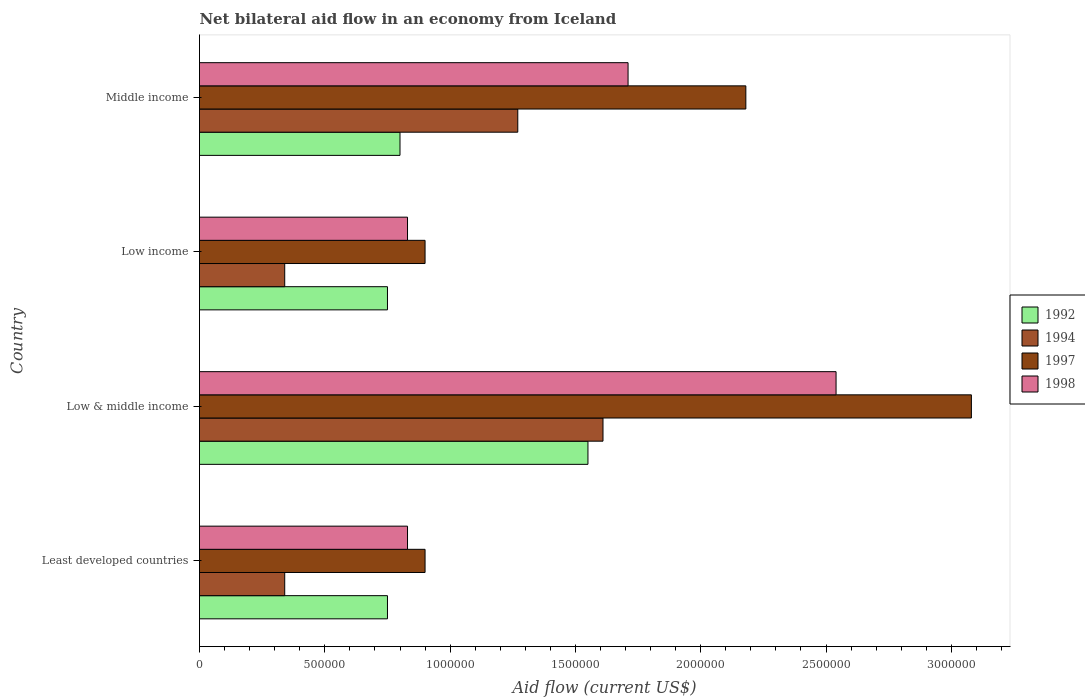How many groups of bars are there?
Keep it short and to the point. 4. Are the number of bars per tick equal to the number of legend labels?
Ensure brevity in your answer.  Yes. Are the number of bars on each tick of the Y-axis equal?
Your answer should be very brief. Yes. What is the label of the 3rd group of bars from the top?
Your answer should be compact. Low & middle income. In how many cases, is the number of bars for a given country not equal to the number of legend labels?
Your answer should be compact. 0. What is the net bilateral aid flow in 1992 in Least developed countries?
Offer a terse response. 7.50e+05. Across all countries, what is the maximum net bilateral aid flow in 1994?
Offer a terse response. 1.61e+06. In which country was the net bilateral aid flow in 1998 minimum?
Ensure brevity in your answer.  Least developed countries. What is the total net bilateral aid flow in 1997 in the graph?
Make the answer very short. 7.06e+06. What is the difference between the net bilateral aid flow in 1997 in Least developed countries and that in Middle income?
Your response must be concise. -1.28e+06. What is the average net bilateral aid flow in 1998 per country?
Offer a terse response. 1.48e+06. What is the difference between the net bilateral aid flow in 1997 and net bilateral aid flow in 1992 in Middle income?
Offer a terse response. 1.38e+06. In how many countries, is the net bilateral aid flow in 1998 greater than 1700000 US$?
Your answer should be very brief. 2. What is the ratio of the net bilateral aid flow in 1998 in Low & middle income to that in Middle income?
Your answer should be very brief. 1.49. Is the net bilateral aid flow in 1992 in Least developed countries less than that in Middle income?
Your answer should be very brief. Yes. What is the difference between the highest and the second highest net bilateral aid flow in 1998?
Ensure brevity in your answer.  8.30e+05. What is the difference between the highest and the lowest net bilateral aid flow in 1994?
Provide a succinct answer. 1.27e+06. In how many countries, is the net bilateral aid flow in 1997 greater than the average net bilateral aid flow in 1997 taken over all countries?
Your response must be concise. 2. Is the sum of the net bilateral aid flow in 1992 in Low & middle income and Low income greater than the maximum net bilateral aid flow in 1998 across all countries?
Provide a short and direct response. No. Is it the case that in every country, the sum of the net bilateral aid flow in 1998 and net bilateral aid flow in 1997 is greater than the net bilateral aid flow in 1992?
Your answer should be compact. Yes. Are all the bars in the graph horizontal?
Offer a very short reply. Yes. What is the difference between two consecutive major ticks on the X-axis?
Offer a terse response. 5.00e+05. Are the values on the major ticks of X-axis written in scientific E-notation?
Ensure brevity in your answer.  No. Does the graph contain any zero values?
Keep it short and to the point. No. Does the graph contain grids?
Make the answer very short. No. Where does the legend appear in the graph?
Offer a terse response. Center right. How many legend labels are there?
Your response must be concise. 4. What is the title of the graph?
Provide a succinct answer. Net bilateral aid flow in an economy from Iceland. Does "1992" appear as one of the legend labels in the graph?
Offer a very short reply. Yes. What is the Aid flow (current US$) of 1992 in Least developed countries?
Your response must be concise. 7.50e+05. What is the Aid flow (current US$) of 1994 in Least developed countries?
Give a very brief answer. 3.40e+05. What is the Aid flow (current US$) of 1997 in Least developed countries?
Offer a terse response. 9.00e+05. What is the Aid flow (current US$) of 1998 in Least developed countries?
Make the answer very short. 8.30e+05. What is the Aid flow (current US$) in 1992 in Low & middle income?
Make the answer very short. 1.55e+06. What is the Aid flow (current US$) in 1994 in Low & middle income?
Provide a short and direct response. 1.61e+06. What is the Aid flow (current US$) of 1997 in Low & middle income?
Make the answer very short. 3.08e+06. What is the Aid flow (current US$) in 1998 in Low & middle income?
Make the answer very short. 2.54e+06. What is the Aid flow (current US$) in 1992 in Low income?
Ensure brevity in your answer.  7.50e+05. What is the Aid flow (current US$) in 1994 in Low income?
Give a very brief answer. 3.40e+05. What is the Aid flow (current US$) in 1998 in Low income?
Your answer should be very brief. 8.30e+05. What is the Aid flow (current US$) in 1992 in Middle income?
Make the answer very short. 8.00e+05. What is the Aid flow (current US$) of 1994 in Middle income?
Provide a succinct answer. 1.27e+06. What is the Aid flow (current US$) in 1997 in Middle income?
Offer a terse response. 2.18e+06. What is the Aid flow (current US$) of 1998 in Middle income?
Your response must be concise. 1.71e+06. Across all countries, what is the maximum Aid flow (current US$) of 1992?
Your answer should be compact. 1.55e+06. Across all countries, what is the maximum Aid flow (current US$) of 1994?
Your answer should be very brief. 1.61e+06. Across all countries, what is the maximum Aid flow (current US$) in 1997?
Provide a short and direct response. 3.08e+06. Across all countries, what is the maximum Aid flow (current US$) in 1998?
Your answer should be compact. 2.54e+06. Across all countries, what is the minimum Aid flow (current US$) in 1992?
Keep it short and to the point. 7.50e+05. Across all countries, what is the minimum Aid flow (current US$) of 1994?
Provide a succinct answer. 3.40e+05. Across all countries, what is the minimum Aid flow (current US$) of 1998?
Your answer should be compact. 8.30e+05. What is the total Aid flow (current US$) of 1992 in the graph?
Your response must be concise. 3.85e+06. What is the total Aid flow (current US$) in 1994 in the graph?
Your response must be concise. 3.56e+06. What is the total Aid flow (current US$) of 1997 in the graph?
Keep it short and to the point. 7.06e+06. What is the total Aid flow (current US$) in 1998 in the graph?
Your answer should be compact. 5.91e+06. What is the difference between the Aid flow (current US$) in 1992 in Least developed countries and that in Low & middle income?
Your response must be concise. -8.00e+05. What is the difference between the Aid flow (current US$) of 1994 in Least developed countries and that in Low & middle income?
Ensure brevity in your answer.  -1.27e+06. What is the difference between the Aid flow (current US$) of 1997 in Least developed countries and that in Low & middle income?
Your response must be concise. -2.18e+06. What is the difference between the Aid flow (current US$) in 1998 in Least developed countries and that in Low & middle income?
Make the answer very short. -1.71e+06. What is the difference between the Aid flow (current US$) in 1992 in Least developed countries and that in Low income?
Ensure brevity in your answer.  0. What is the difference between the Aid flow (current US$) of 1994 in Least developed countries and that in Low income?
Provide a short and direct response. 0. What is the difference between the Aid flow (current US$) in 1997 in Least developed countries and that in Low income?
Make the answer very short. 0. What is the difference between the Aid flow (current US$) of 1998 in Least developed countries and that in Low income?
Your response must be concise. 0. What is the difference between the Aid flow (current US$) of 1992 in Least developed countries and that in Middle income?
Your answer should be very brief. -5.00e+04. What is the difference between the Aid flow (current US$) of 1994 in Least developed countries and that in Middle income?
Provide a short and direct response. -9.30e+05. What is the difference between the Aid flow (current US$) of 1997 in Least developed countries and that in Middle income?
Offer a terse response. -1.28e+06. What is the difference between the Aid flow (current US$) in 1998 in Least developed countries and that in Middle income?
Your answer should be very brief. -8.80e+05. What is the difference between the Aid flow (current US$) in 1992 in Low & middle income and that in Low income?
Your answer should be compact. 8.00e+05. What is the difference between the Aid flow (current US$) in 1994 in Low & middle income and that in Low income?
Offer a very short reply. 1.27e+06. What is the difference between the Aid flow (current US$) in 1997 in Low & middle income and that in Low income?
Provide a short and direct response. 2.18e+06. What is the difference between the Aid flow (current US$) of 1998 in Low & middle income and that in Low income?
Your response must be concise. 1.71e+06. What is the difference between the Aid flow (current US$) of 1992 in Low & middle income and that in Middle income?
Keep it short and to the point. 7.50e+05. What is the difference between the Aid flow (current US$) of 1994 in Low & middle income and that in Middle income?
Offer a terse response. 3.40e+05. What is the difference between the Aid flow (current US$) of 1998 in Low & middle income and that in Middle income?
Ensure brevity in your answer.  8.30e+05. What is the difference between the Aid flow (current US$) in 1992 in Low income and that in Middle income?
Keep it short and to the point. -5.00e+04. What is the difference between the Aid flow (current US$) in 1994 in Low income and that in Middle income?
Give a very brief answer. -9.30e+05. What is the difference between the Aid flow (current US$) in 1997 in Low income and that in Middle income?
Your answer should be very brief. -1.28e+06. What is the difference between the Aid flow (current US$) of 1998 in Low income and that in Middle income?
Offer a terse response. -8.80e+05. What is the difference between the Aid flow (current US$) of 1992 in Least developed countries and the Aid flow (current US$) of 1994 in Low & middle income?
Your answer should be very brief. -8.60e+05. What is the difference between the Aid flow (current US$) in 1992 in Least developed countries and the Aid flow (current US$) in 1997 in Low & middle income?
Provide a short and direct response. -2.33e+06. What is the difference between the Aid flow (current US$) in 1992 in Least developed countries and the Aid flow (current US$) in 1998 in Low & middle income?
Your answer should be very brief. -1.79e+06. What is the difference between the Aid flow (current US$) in 1994 in Least developed countries and the Aid flow (current US$) in 1997 in Low & middle income?
Make the answer very short. -2.74e+06. What is the difference between the Aid flow (current US$) of 1994 in Least developed countries and the Aid flow (current US$) of 1998 in Low & middle income?
Provide a succinct answer. -2.20e+06. What is the difference between the Aid flow (current US$) of 1997 in Least developed countries and the Aid flow (current US$) of 1998 in Low & middle income?
Offer a very short reply. -1.64e+06. What is the difference between the Aid flow (current US$) in 1992 in Least developed countries and the Aid flow (current US$) in 1997 in Low income?
Ensure brevity in your answer.  -1.50e+05. What is the difference between the Aid flow (current US$) in 1994 in Least developed countries and the Aid flow (current US$) in 1997 in Low income?
Your answer should be compact. -5.60e+05. What is the difference between the Aid flow (current US$) of 1994 in Least developed countries and the Aid flow (current US$) of 1998 in Low income?
Keep it short and to the point. -4.90e+05. What is the difference between the Aid flow (current US$) in 1992 in Least developed countries and the Aid flow (current US$) in 1994 in Middle income?
Provide a succinct answer. -5.20e+05. What is the difference between the Aid flow (current US$) in 1992 in Least developed countries and the Aid flow (current US$) in 1997 in Middle income?
Ensure brevity in your answer.  -1.43e+06. What is the difference between the Aid flow (current US$) in 1992 in Least developed countries and the Aid flow (current US$) in 1998 in Middle income?
Your answer should be very brief. -9.60e+05. What is the difference between the Aid flow (current US$) of 1994 in Least developed countries and the Aid flow (current US$) of 1997 in Middle income?
Give a very brief answer. -1.84e+06. What is the difference between the Aid flow (current US$) of 1994 in Least developed countries and the Aid flow (current US$) of 1998 in Middle income?
Offer a very short reply. -1.37e+06. What is the difference between the Aid flow (current US$) of 1997 in Least developed countries and the Aid flow (current US$) of 1998 in Middle income?
Your response must be concise. -8.10e+05. What is the difference between the Aid flow (current US$) in 1992 in Low & middle income and the Aid flow (current US$) in 1994 in Low income?
Offer a terse response. 1.21e+06. What is the difference between the Aid flow (current US$) in 1992 in Low & middle income and the Aid flow (current US$) in 1997 in Low income?
Your answer should be very brief. 6.50e+05. What is the difference between the Aid flow (current US$) of 1992 in Low & middle income and the Aid flow (current US$) of 1998 in Low income?
Your response must be concise. 7.20e+05. What is the difference between the Aid flow (current US$) of 1994 in Low & middle income and the Aid flow (current US$) of 1997 in Low income?
Give a very brief answer. 7.10e+05. What is the difference between the Aid flow (current US$) in 1994 in Low & middle income and the Aid flow (current US$) in 1998 in Low income?
Keep it short and to the point. 7.80e+05. What is the difference between the Aid flow (current US$) in 1997 in Low & middle income and the Aid flow (current US$) in 1998 in Low income?
Give a very brief answer. 2.25e+06. What is the difference between the Aid flow (current US$) of 1992 in Low & middle income and the Aid flow (current US$) of 1997 in Middle income?
Make the answer very short. -6.30e+05. What is the difference between the Aid flow (current US$) in 1992 in Low & middle income and the Aid flow (current US$) in 1998 in Middle income?
Provide a short and direct response. -1.60e+05. What is the difference between the Aid flow (current US$) in 1994 in Low & middle income and the Aid flow (current US$) in 1997 in Middle income?
Offer a very short reply. -5.70e+05. What is the difference between the Aid flow (current US$) in 1997 in Low & middle income and the Aid flow (current US$) in 1998 in Middle income?
Ensure brevity in your answer.  1.37e+06. What is the difference between the Aid flow (current US$) of 1992 in Low income and the Aid flow (current US$) of 1994 in Middle income?
Your answer should be very brief. -5.20e+05. What is the difference between the Aid flow (current US$) of 1992 in Low income and the Aid flow (current US$) of 1997 in Middle income?
Your response must be concise. -1.43e+06. What is the difference between the Aid flow (current US$) of 1992 in Low income and the Aid flow (current US$) of 1998 in Middle income?
Your answer should be very brief. -9.60e+05. What is the difference between the Aid flow (current US$) of 1994 in Low income and the Aid flow (current US$) of 1997 in Middle income?
Make the answer very short. -1.84e+06. What is the difference between the Aid flow (current US$) of 1994 in Low income and the Aid flow (current US$) of 1998 in Middle income?
Offer a very short reply. -1.37e+06. What is the difference between the Aid flow (current US$) in 1997 in Low income and the Aid flow (current US$) in 1998 in Middle income?
Ensure brevity in your answer.  -8.10e+05. What is the average Aid flow (current US$) in 1992 per country?
Your response must be concise. 9.62e+05. What is the average Aid flow (current US$) of 1994 per country?
Provide a succinct answer. 8.90e+05. What is the average Aid flow (current US$) in 1997 per country?
Offer a very short reply. 1.76e+06. What is the average Aid flow (current US$) in 1998 per country?
Offer a very short reply. 1.48e+06. What is the difference between the Aid flow (current US$) in 1992 and Aid flow (current US$) in 1998 in Least developed countries?
Offer a terse response. -8.00e+04. What is the difference between the Aid flow (current US$) of 1994 and Aid flow (current US$) of 1997 in Least developed countries?
Ensure brevity in your answer.  -5.60e+05. What is the difference between the Aid flow (current US$) of 1994 and Aid flow (current US$) of 1998 in Least developed countries?
Offer a very short reply. -4.90e+05. What is the difference between the Aid flow (current US$) of 1997 and Aid flow (current US$) of 1998 in Least developed countries?
Provide a succinct answer. 7.00e+04. What is the difference between the Aid flow (current US$) in 1992 and Aid flow (current US$) in 1994 in Low & middle income?
Offer a terse response. -6.00e+04. What is the difference between the Aid flow (current US$) of 1992 and Aid flow (current US$) of 1997 in Low & middle income?
Keep it short and to the point. -1.53e+06. What is the difference between the Aid flow (current US$) in 1992 and Aid flow (current US$) in 1998 in Low & middle income?
Keep it short and to the point. -9.90e+05. What is the difference between the Aid flow (current US$) of 1994 and Aid flow (current US$) of 1997 in Low & middle income?
Provide a short and direct response. -1.47e+06. What is the difference between the Aid flow (current US$) of 1994 and Aid flow (current US$) of 1998 in Low & middle income?
Your answer should be compact. -9.30e+05. What is the difference between the Aid flow (current US$) of 1997 and Aid flow (current US$) of 1998 in Low & middle income?
Offer a terse response. 5.40e+05. What is the difference between the Aid flow (current US$) in 1992 and Aid flow (current US$) in 1994 in Low income?
Your response must be concise. 4.10e+05. What is the difference between the Aid flow (current US$) of 1992 and Aid flow (current US$) of 1997 in Low income?
Keep it short and to the point. -1.50e+05. What is the difference between the Aid flow (current US$) of 1992 and Aid flow (current US$) of 1998 in Low income?
Your answer should be compact. -8.00e+04. What is the difference between the Aid flow (current US$) of 1994 and Aid flow (current US$) of 1997 in Low income?
Your answer should be compact. -5.60e+05. What is the difference between the Aid flow (current US$) of 1994 and Aid flow (current US$) of 1998 in Low income?
Give a very brief answer. -4.90e+05. What is the difference between the Aid flow (current US$) in 1997 and Aid flow (current US$) in 1998 in Low income?
Your answer should be compact. 7.00e+04. What is the difference between the Aid flow (current US$) of 1992 and Aid flow (current US$) of 1994 in Middle income?
Ensure brevity in your answer.  -4.70e+05. What is the difference between the Aid flow (current US$) in 1992 and Aid flow (current US$) in 1997 in Middle income?
Your answer should be very brief. -1.38e+06. What is the difference between the Aid flow (current US$) of 1992 and Aid flow (current US$) of 1998 in Middle income?
Provide a succinct answer. -9.10e+05. What is the difference between the Aid flow (current US$) of 1994 and Aid flow (current US$) of 1997 in Middle income?
Offer a terse response. -9.10e+05. What is the difference between the Aid flow (current US$) in 1994 and Aid flow (current US$) in 1998 in Middle income?
Give a very brief answer. -4.40e+05. What is the ratio of the Aid flow (current US$) of 1992 in Least developed countries to that in Low & middle income?
Provide a short and direct response. 0.48. What is the ratio of the Aid flow (current US$) of 1994 in Least developed countries to that in Low & middle income?
Give a very brief answer. 0.21. What is the ratio of the Aid flow (current US$) in 1997 in Least developed countries to that in Low & middle income?
Your answer should be compact. 0.29. What is the ratio of the Aid flow (current US$) in 1998 in Least developed countries to that in Low & middle income?
Your response must be concise. 0.33. What is the ratio of the Aid flow (current US$) of 1994 in Least developed countries to that in Low income?
Offer a very short reply. 1. What is the ratio of the Aid flow (current US$) in 1997 in Least developed countries to that in Low income?
Your response must be concise. 1. What is the ratio of the Aid flow (current US$) of 1998 in Least developed countries to that in Low income?
Your answer should be very brief. 1. What is the ratio of the Aid flow (current US$) of 1994 in Least developed countries to that in Middle income?
Ensure brevity in your answer.  0.27. What is the ratio of the Aid flow (current US$) in 1997 in Least developed countries to that in Middle income?
Ensure brevity in your answer.  0.41. What is the ratio of the Aid flow (current US$) of 1998 in Least developed countries to that in Middle income?
Your answer should be compact. 0.49. What is the ratio of the Aid flow (current US$) in 1992 in Low & middle income to that in Low income?
Give a very brief answer. 2.07. What is the ratio of the Aid flow (current US$) of 1994 in Low & middle income to that in Low income?
Your response must be concise. 4.74. What is the ratio of the Aid flow (current US$) in 1997 in Low & middle income to that in Low income?
Your answer should be compact. 3.42. What is the ratio of the Aid flow (current US$) in 1998 in Low & middle income to that in Low income?
Keep it short and to the point. 3.06. What is the ratio of the Aid flow (current US$) of 1992 in Low & middle income to that in Middle income?
Your answer should be very brief. 1.94. What is the ratio of the Aid flow (current US$) of 1994 in Low & middle income to that in Middle income?
Provide a succinct answer. 1.27. What is the ratio of the Aid flow (current US$) of 1997 in Low & middle income to that in Middle income?
Your answer should be very brief. 1.41. What is the ratio of the Aid flow (current US$) in 1998 in Low & middle income to that in Middle income?
Give a very brief answer. 1.49. What is the ratio of the Aid flow (current US$) of 1994 in Low income to that in Middle income?
Keep it short and to the point. 0.27. What is the ratio of the Aid flow (current US$) of 1997 in Low income to that in Middle income?
Offer a terse response. 0.41. What is the ratio of the Aid flow (current US$) in 1998 in Low income to that in Middle income?
Ensure brevity in your answer.  0.49. What is the difference between the highest and the second highest Aid flow (current US$) in 1992?
Ensure brevity in your answer.  7.50e+05. What is the difference between the highest and the second highest Aid flow (current US$) in 1994?
Make the answer very short. 3.40e+05. What is the difference between the highest and the second highest Aid flow (current US$) in 1998?
Offer a terse response. 8.30e+05. What is the difference between the highest and the lowest Aid flow (current US$) in 1994?
Make the answer very short. 1.27e+06. What is the difference between the highest and the lowest Aid flow (current US$) in 1997?
Keep it short and to the point. 2.18e+06. What is the difference between the highest and the lowest Aid flow (current US$) of 1998?
Provide a succinct answer. 1.71e+06. 